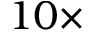<formula> <loc_0><loc_0><loc_500><loc_500>1 0 \times</formula> 